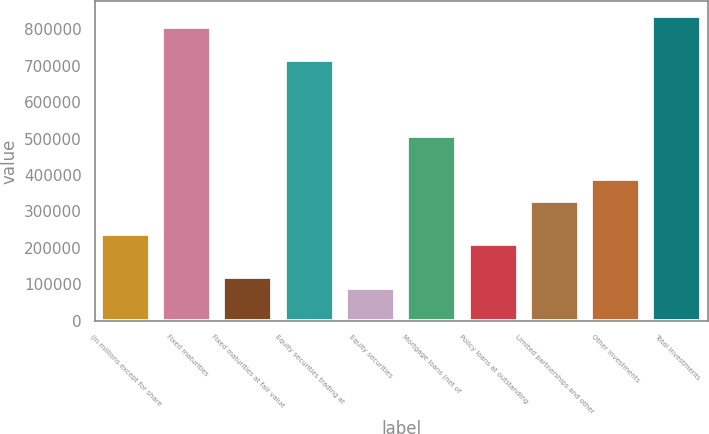<chart> <loc_0><loc_0><loc_500><loc_500><bar_chart><fcel>(In millions except for share<fcel>Fixed maturities<fcel>Fixed maturities at fair value<fcel>Equity securities trading at<fcel>Equity securities<fcel>Mortgage loans (net of<fcel>Policy loans at outstanding<fcel>Limited partnerships and other<fcel>Other investments<fcel>Total investments<nl><fcel>238811<fcel>805977<fcel>119408<fcel>716424<fcel>89557.4<fcel>507469<fcel>208961<fcel>328364<fcel>388065<fcel>835827<nl></chart> 